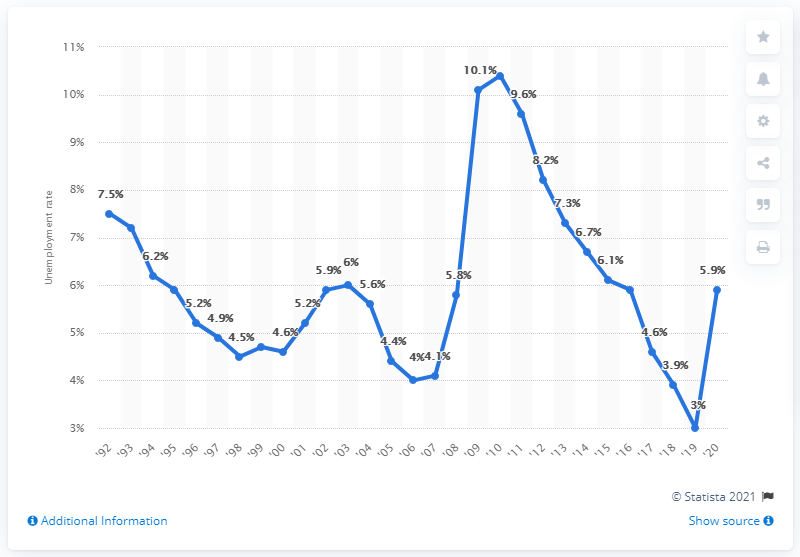Specify some key components in this picture. Alabama's highest unemployment rate in 2010 was 10.4%. 